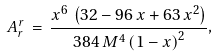<formula> <loc_0><loc_0><loc_500><loc_500>A ^ { r } _ { r } \, = \, { \frac { { x ^ { 6 } } \, \left ( 3 2 - 9 6 \, x + 6 3 \, { x ^ { 2 } } \right ) } { 3 8 4 \, { M ^ { 4 } } \, { { \left ( 1 - x \right ) } ^ { 2 } } } } ,</formula> 